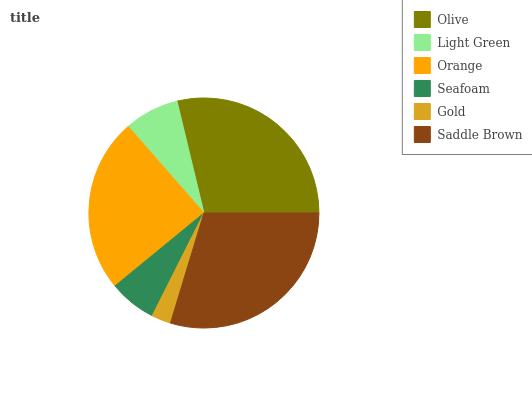Is Gold the minimum?
Answer yes or no. Yes. Is Saddle Brown the maximum?
Answer yes or no. Yes. Is Light Green the minimum?
Answer yes or no. No. Is Light Green the maximum?
Answer yes or no. No. Is Olive greater than Light Green?
Answer yes or no. Yes. Is Light Green less than Olive?
Answer yes or no. Yes. Is Light Green greater than Olive?
Answer yes or no. No. Is Olive less than Light Green?
Answer yes or no. No. Is Orange the high median?
Answer yes or no. Yes. Is Light Green the low median?
Answer yes or no. Yes. Is Light Green the high median?
Answer yes or no. No. Is Seafoam the low median?
Answer yes or no. No. 